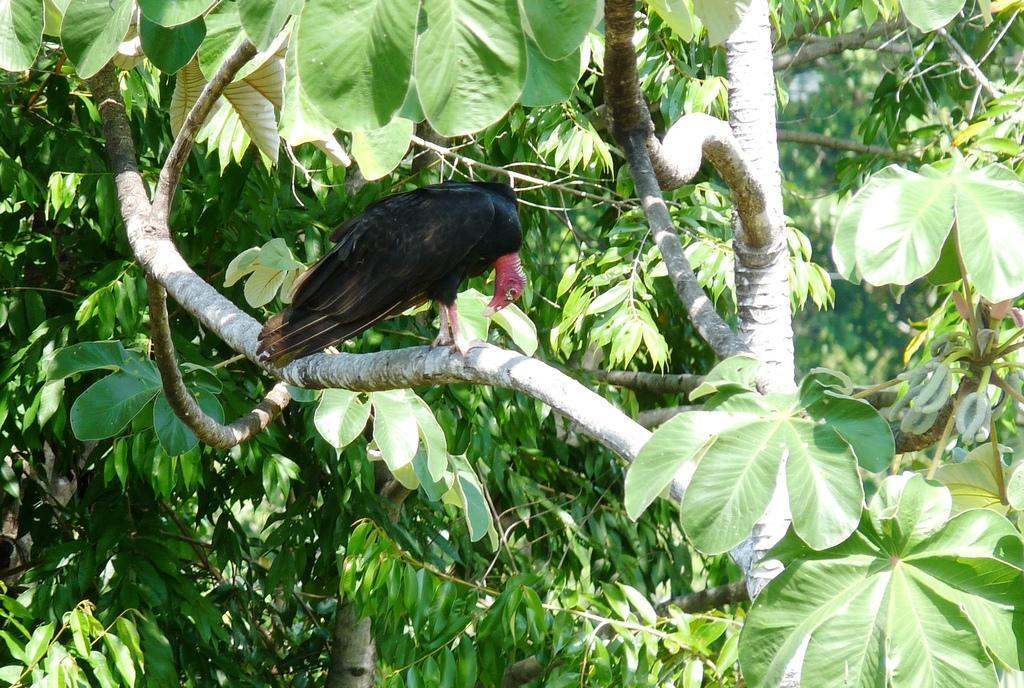In one or two sentences, can you explain what this image depicts? In this image, we can see a bird sitting on a branch and we can see some green leaves. 